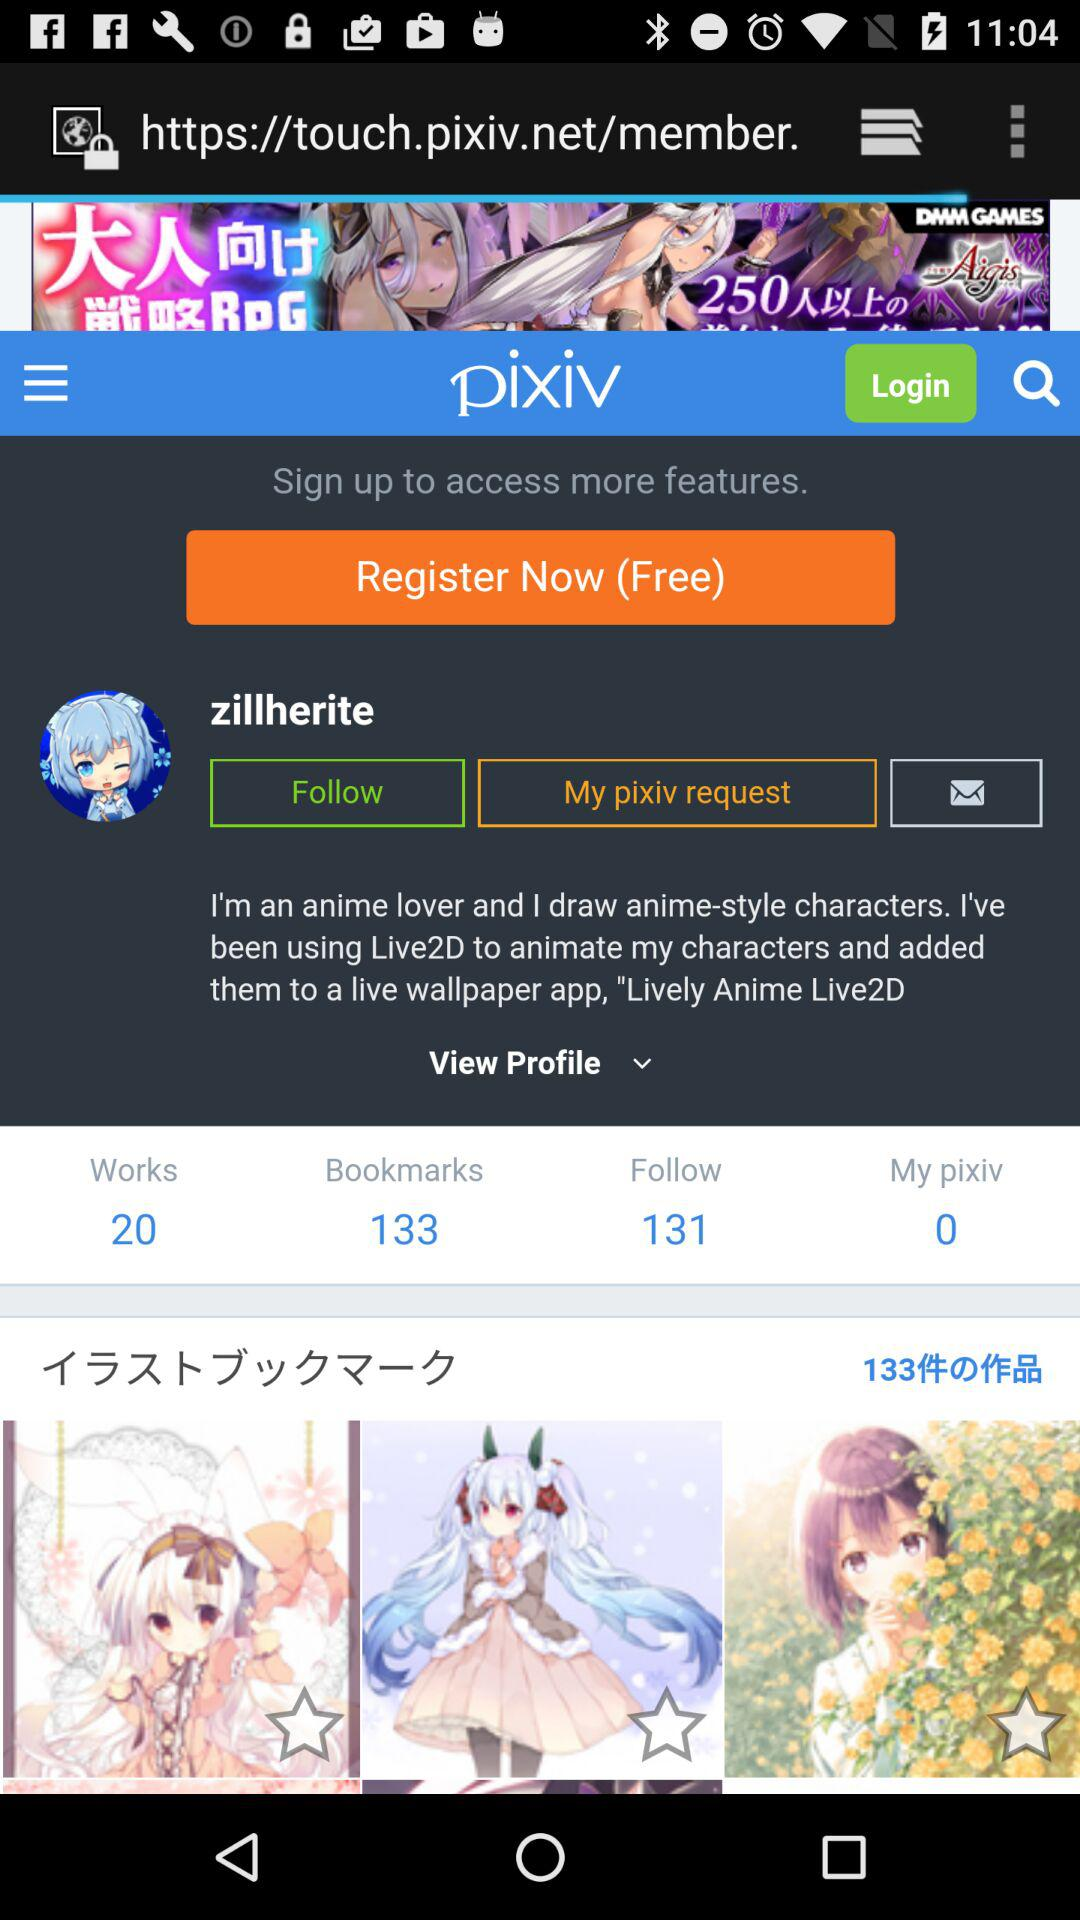How many bookmarks are there? There are 133 bookmarks. 